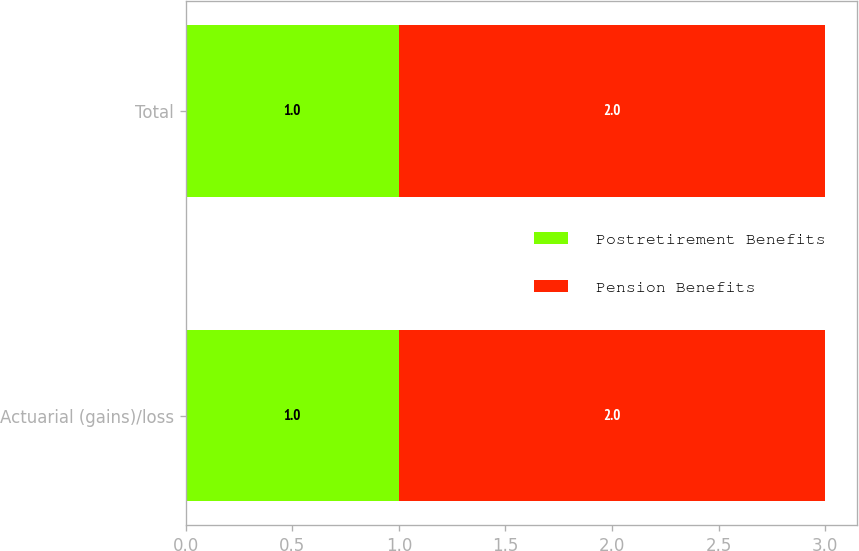Convert chart to OTSL. <chart><loc_0><loc_0><loc_500><loc_500><stacked_bar_chart><ecel><fcel>Actuarial (gains)/loss<fcel>Total<nl><fcel>Postretirement Benefits<fcel>1<fcel>1<nl><fcel>Pension Benefits<fcel>2<fcel>2<nl></chart> 